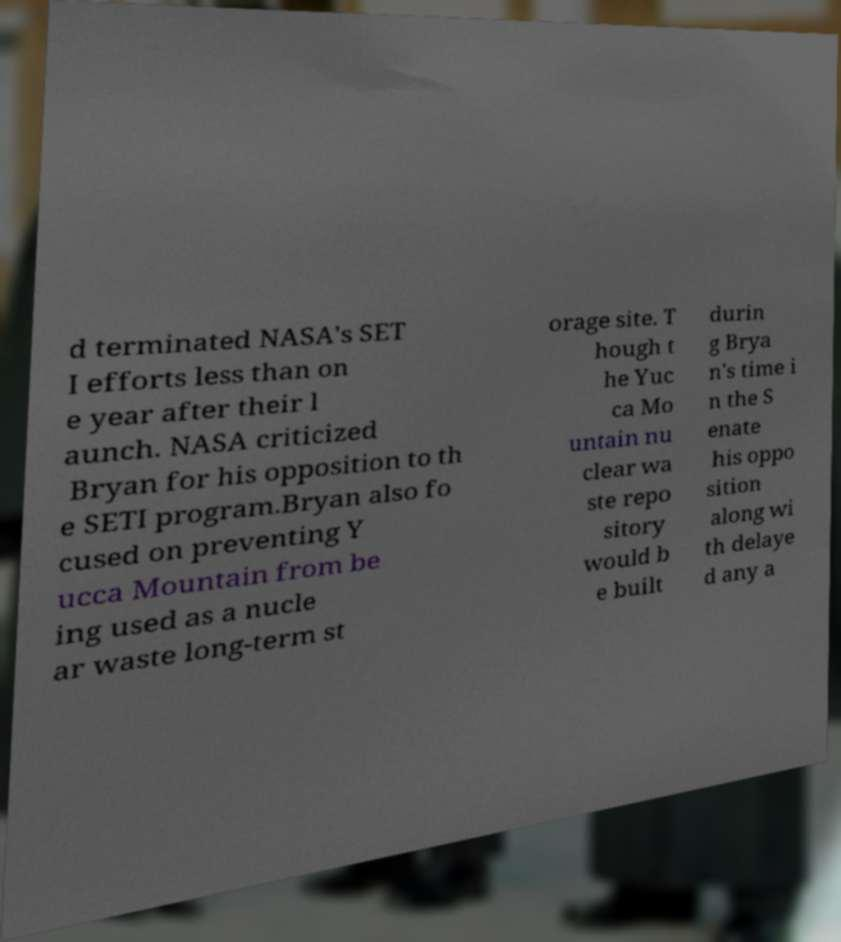What messages or text are displayed in this image? I need them in a readable, typed format. d terminated NASA's SET I efforts less than on e year after their l aunch. NASA criticized Bryan for his opposition to th e SETI program.Bryan also fo cused on preventing Y ucca Mountain from be ing used as a nucle ar waste long-term st orage site. T hough t he Yuc ca Mo untain nu clear wa ste repo sitory would b e built durin g Brya n's time i n the S enate his oppo sition along wi th delaye d any a 